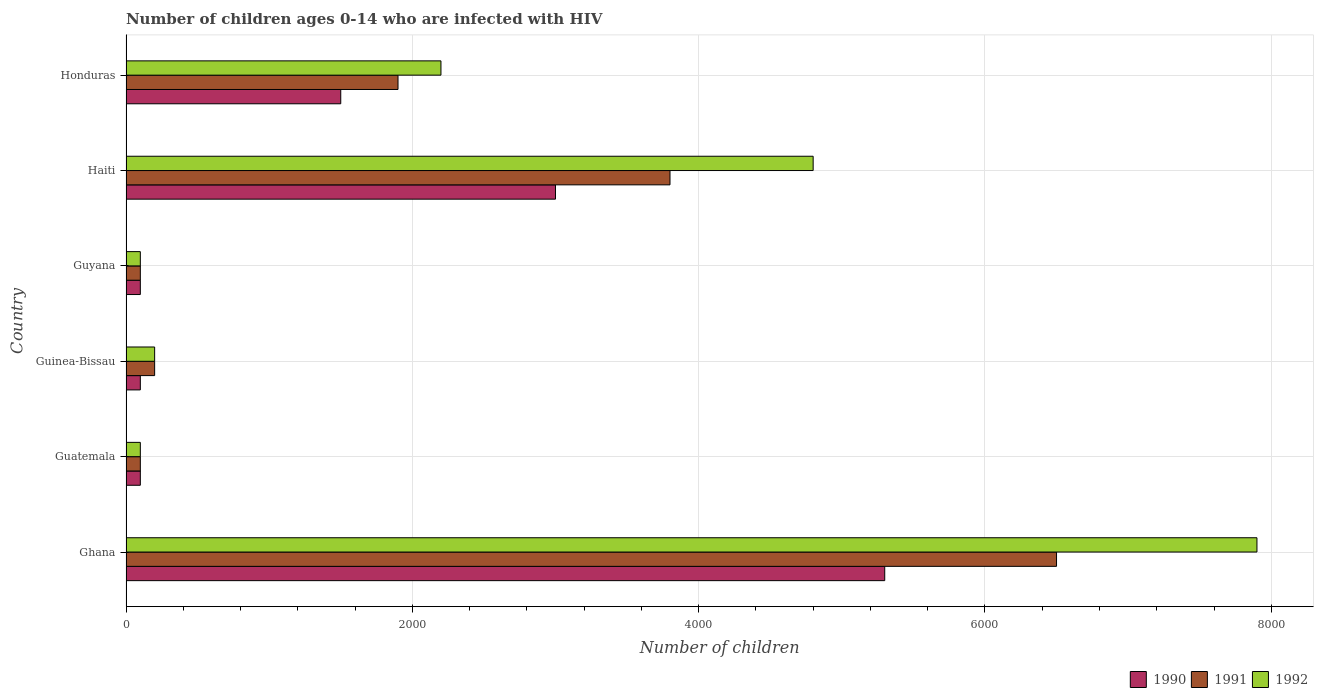How many groups of bars are there?
Your answer should be very brief. 6. Are the number of bars per tick equal to the number of legend labels?
Give a very brief answer. Yes. How many bars are there on the 5th tick from the bottom?
Make the answer very short. 3. What is the label of the 6th group of bars from the top?
Provide a succinct answer. Ghana. In how many cases, is the number of bars for a given country not equal to the number of legend labels?
Provide a short and direct response. 0. What is the number of HIV infected children in 1992 in Guatemala?
Provide a short and direct response. 100. Across all countries, what is the maximum number of HIV infected children in 1990?
Ensure brevity in your answer.  5300. Across all countries, what is the minimum number of HIV infected children in 1990?
Give a very brief answer. 100. In which country was the number of HIV infected children in 1990 maximum?
Your answer should be very brief. Ghana. In which country was the number of HIV infected children in 1992 minimum?
Offer a very short reply. Guatemala. What is the total number of HIV infected children in 1991 in the graph?
Your answer should be very brief. 1.26e+04. What is the difference between the number of HIV infected children in 1992 in Guyana and that in Haiti?
Provide a succinct answer. -4700. What is the difference between the number of HIV infected children in 1991 in Guyana and the number of HIV infected children in 1990 in Guatemala?
Keep it short and to the point. 0. What is the average number of HIV infected children in 1990 per country?
Offer a very short reply. 1683.33. What is the difference between the number of HIV infected children in 1990 and number of HIV infected children in 1991 in Guyana?
Your answer should be compact. 0. In how many countries, is the number of HIV infected children in 1990 greater than 7600 ?
Your answer should be very brief. 0. What is the ratio of the number of HIV infected children in 1990 in Guyana to that in Honduras?
Provide a short and direct response. 0.07. Is the number of HIV infected children in 1990 in Ghana less than that in Guatemala?
Offer a very short reply. No. What is the difference between the highest and the second highest number of HIV infected children in 1990?
Offer a terse response. 2300. What is the difference between the highest and the lowest number of HIV infected children in 1991?
Your response must be concise. 6400. Is the sum of the number of HIV infected children in 1992 in Ghana and Guinea-Bissau greater than the maximum number of HIV infected children in 1991 across all countries?
Give a very brief answer. Yes. What does the 2nd bar from the bottom in Honduras represents?
Offer a very short reply. 1991. Is it the case that in every country, the sum of the number of HIV infected children in 1991 and number of HIV infected children in 1992 is greater than the number of HIV infected children in 1990?
Provide a short and direct response. Yes. How many bars are there?
Offer a terse response. 18. How many countries are there in the graph?
Keep it short and to the point. 6. Does the graph contain grids?
Provide a succinct answer. Yes. Where does the legend appear in the graph?
Give a very brief answer. Bottom right. How many legend labels are there?
Your answer should be very brief. 3. How are the legend labels stacked?
Your answer should be compact. Horizontal. What is the title of the graph?
Give a very brief answer. Number of children ages 0-14 who are infected with HIV. Does "1979" appear as one of the legend labels in the graph?
Ensure brevity in your answer.  No. What is the label or title of the X-axis?
Provide a short and direct response. Number of children. What is the label or title of the Y-axis?
Your answer should be compact. Country. What is the Number of children of 1990 in Ghana?
Your answer should be compact. 5300. What is the Number of children of 1991 in Ghana?
Your answer should be very brief. 6500. What is the Number of children of 1992 in Ghana?
Give a very brief answer. 7900. What is the Number of children of 1991 in Guatemala?
Offer a very short reply. 100. What is the Number of children in 1992 in Guatemala?
Ensure brevity in your answer.  100. What is the Number of children of 1990 in Guinea-Bissau?
Offer a terse response. 100. What is the Number of children of 1991 in Guinea-Bissau?
Provide a short and direct response. 200. What is the Number of children of 1991 in Guyana?
Your response must be concise. 100. What is the Number of children of 1990 in Haiti?
Your response must be concise. 3000. What is the Number of children of 1991 in Haiti?
Provide a short and direct response. 3800. What is the Number of children in 1992 in Haiti?
Ensure brevity in your answer.  4800. What is the Number of children in 1990 in Honduras?
Provide a short and direct response. 1500. What is the Number of children of 1991 in Honduras?
Ensure brevity in your answer.  1900. What is the Number of children of 1992 in Honduras?
Your answer should be very brief. 2200. Across all countries, what is the maximum Number of children of 1990?
Give a very brief answer. 5300. Across all countries, what is the maximum Number of children in 1991?
Keep it short and to the point. 6500. Across all countries, what is the maximum Number of children of 1992?
Your response must be concise. 7900. Across all countries, what is the minimum Number of children of 1991?
Ensure brevity in your answer.  100. Across all countries, what is the minimum Number of children of 1992?
Your answer should be compact. 100. What is the total Number of children of 1990 in the graph?
Make the answer very short. 1.01e+04. What is the total Number of children of 1991 in the graph?
Offer a very short reply. 1.26e+04. What is the total Number of children of 1992 in the graph?
Keep it short and to the point. 1.53e+04. What is the difference between the Number of children in 1990 in Ghana and that in Guatemala?
Make the answer very short. 5200. What is the difference between the Number of children in 1991 in Ghana and that in Guatemala?
Ensure brevity in your answer.  6400. What is the difference between the Number of children of 1992 in Ghana and that in Guatemala?
Provide a succinct answer. 7800. What is the difference between the Number of children in 1990 in Ghana and that in Guinea-Bissau?
Your answer should be very brief. 5200. What is the difference between the Number of children in 1991 in Ghana and that in Guinea-Bissau?
Your response must be concise. 6300. What is the difference between the Number of children of 1992 in Ghana and that in Guinea-Bissau?
Your answer should be very brief. 7700. What is the difference between the Number of children in 1990 in Ghana and that in Guyana?
Ensure brevity in your answer.  5200. What is the difference between the Number of children in 1991 in Ghana and that in Guyana?
Your response must be concise. 6400. What is the difference between the Number of children in 1992 in Ghana and that in Guyana?
Ensure brevity in your answer.  7800. What is the difference between the Number of children in 1990 in Ghana and that in Haiti?
Provide a short and direct response. 2300. What is the difference between the Number of children in 1991 in Ghana and that in Haiti?
Your answer should be compact. 2700. What is the difference between the Number of children in 1992 in Ghana and that in Haiti?
Your answer should be very brief. 3100. What is the difference between the Number of children of 1990 in Ghana and that in Honduras?
Your answer should be very brief. 3800. What is the difference between the Number of children of 1991 in Ghana and that in Honduras?
Keep it short and to the point. 4600. What is the difference between the Number of children of 1992 in Ghana and that in Honduras?
Offer a very short reply. 5700. What is the difference between the Number of children of 1991 in Guatemala and that in Guinea-Bissau?
Ensure brevity in your answer.  -100. What is the difference between the Number of children of 1992 in Guatemala and that in Guinea-Bissau?
Your answer should be compact. -100. What is the difference between the Number of children of 1990 in Guatemala and that in Guyana?
Your answer should be compact. 0. What is the difference between the Number of children of 1991 in Guatemala and that in Guyana?
Offer a terse response. 0. What is the difference between the Number of children in 1990 in Guatemala and that in Haiti?
Your answer should be very brief. -2900. What is the difference between the Number of children of 1991 in Guatemala and that in Haiti?
Ensure brevity in your answer.  -3700. What is the difference between the Number of children of 1992 in Guatemala and that in Haiti?
Your response must be concise. -4700. What is the difference between the Number of children in 1990 in Guatemala and that in Honduras?
Your response must be concise. -1400. What is the difference between the Number of children of 1991 in Guatemala and that in Honduras?
Ensure brevity in your answer.  -1800. What is the difference between the Number of children of 1992 in Guatemala and that in Honduras?
Give a very brief answer. -2100. What is the difference between the Number of children of 1990 in Guinea-Bissau and that in Guyana?
Your response must be concise. 0. What is the difference between the Number of children in 1990 in Guinea-Bissau and that in Haiti?
Give a very brief answer. -2900. What is the difference between the Number of children of 1991 in Guinea-Bissau and that in Haiti?
Offer a very short reply. -3600. What is the difference between the Number of children in 1992 in Guinea-Bissau and that in Haiti?
Offer a very short reply. -4600. What is the difference between the Number of children of 1990 in Guinea-Bissau and that in Honduras?
Give a very brief answer. -1400. What is the difference between the Number of children of 1991 in Guinea-Bissau and that in Honduras?
Give a very brief answer. -1700. What is the difference between the Number of children of 1992 in Guinea-Bissau and that in Honduras?
Give a very brief answer. -2000. What is the difference between the Number of children in 1990 in Guyana and that in Haiti?
Make the answer very short. -2900. What is the difference between the Number of children in 1991 in Guyana and that in Haiti?
Your answer should be very brief. -3700. What is the difference between the Number of children of 1992 in Guyana and that in Haiti?
Your response must be concise. -4700. What is the difference between the Number of children in 1990 in Guyana and that in Honduras?
Offer a very short reply. -1400. What is the difference between the Number of children in 1991 in Guyana and that in Honduras?
Give a very brief answer. -1800. What is the difference between the Number of children in 1992 in Guyana and that in Honduras?
Your answer should be very brief. -2100. What is the difference between the Number of children of 1990 in Haiti and that in Honduras?
Offer a terse response. 1500. What is the difference between the Number of children in 1991 in Haiti and that in Honduras?
Provide a short and direct response. 1900. What is the difference between the Number of children of 1992 in Haiti and that in Honduras?
Offer a very short reply. 2600. What is the difference between the Number of children of 1990 in Ghana and the Number of children of 1991 in Guatemala?
Ensure brevity in your answer.  5200. What is the difference between the Number of children of 1990 in Ghana and the Number of children of 1992 in Guatemala?
Ensure brevity in your answer.  5200. What is the difference between the Number of children of 1991 in Ghana and the Number of children of 1992 in Guatemala?
Keep it short and to the point. 6400. What is the difference between the Number of children of 1990 in Ghana and the Number of children of 1991 in Guinea-Bissau?
Your response must be concise. 5100. What is the difference between the Number of children in 1990 in Ghana and the Number of children in 1992 in Guinea-Bissau?
Make the answer very short. 5100. What is the difference between the Number of children in 1991 in Ghana and the Number of children in 1992 in Guinea-Bissau?
Your answer should be very brief. 6300. What is the difference between the Number of children of 1990 in Ghana and the Number of children of 1991 in Guyana?
Your answer should be very brief. 5200. What is the difference between the Number of children in 1990 in Ghana and the Number of children in 1992 in Guyana?
Make the answer very short. 5200. What is the difference between the Number of children of 1991 in Ghana and the Number of children of 1992 in Guyana?
Provide a short and direct response. 6400. What is the difference between the Number of children in 1990 in Ghana and the Number of children in 1991 in Haiti?
Provide a short and direct response. 1500. What is the difference between the Number of children in 1990 in Ghana and the Number of children in 1992 in Haiti?
Provide a succinct answer. 500. What is the difference between the Number of children in 1991 in Ghana and the Number of children in 1992 in Haiti?
Your answer should be very brief. 1700. What is the difference between the Number of children of 1990 in Ghana and the Number of children of 1991 in Honduras?
Ensure brevity in your answer.  3400. What is the difference between the Number of children of 1990 in Ghana and the Number of children of 1992 in Honduras?
Make the answer very short. 3100. What is the difference between the Number of children in 1991 in Ghana and the Number of children in 1992 in Honduras?
Provide a succinct answer. 4300. What is the difference between the Number of children in 1990 in Guatemala and the Number of children in 1991 in Guinea-Bissau?
Keep it short and to the point. -100. What is the difference between the Number of children of 1990 in Guatemala and the Number of children of 1992 in Guinea-Bissau?
Make the answer very short. -100. What is the difference between the Number of children of 1991 in Guatemala and the Number of children of 1992 in Guinea-Bissau?
Make the answer very short. -100. What is the difference between the Number of children in 1990 in Guatemala and the Number of children in 1991 in Guyana?
Your response must be concise. 0. What is the difference between the Number of children in 1990 in Guatemala and the Number of children in 1992 in Guyana?
Provide a short and direct response. 0. What is the difference between the Number of children in 1991 in Guatemala and the Number of children in 1992 in Guyana?
Provide a succinct answer. 0. What is the difference between the Number of children of 1990 in Guatemala and the Number of children of 1991 in Haiti?
Provide a succinct answer. -3700. What is the difference between the Number of children in 1990 in Guatemala and the Number of children in 1992 in Haiti?
Offer a terse response. -4700. What is the difference between the Number of children in 1991 in Guatemala and the Number of children in 1992 in Haiti?
Keep it short and to the point. -4700. What is the difference between the Number of children in 1990 in Guatemala and the Number of children in 1991 in Honduras?
Give a very brief answer. -1800. What is the difference between the Number of children of 1990 in Guatemala and the Number of children of 1992 in Honduras?
Your answer should be compact. -2100. What is the difference between the Number of children in 1991 in Guatemala and the Number of children in 1992 in Honduras?
Keep it short and to the point. -2100. What is the difference between the Number of children in 1990 in Guinea-Bissau and the Number of children in 1992 in Guyana?
Provide a succinct answer. 0. What is the difference between the Number of children in 1991 in Guinea-Bissau and the Number of children in 1992 in Guyana?
Provide a succinct answer. 100. What is the difference between the Number of children in 1990 in Guinea-Bissau and the Number of children in 1991 in Haiti?
Your answer should be compact. -3700. What is the difference between the Number of children in 1990 in Guinea-Bissau and the Number of children in 1992 in Haiti?
Provide a succinct answer. -4700. What is the difference between the Number of children of 1991 in Guinea-Bissau and the Number of children of 1992 in Haiti?
Keep it short and to the point. -4600. What is the difference between the Number of children of 1990 in Guinea-Bissau and the Number of children of 1991 in Honduras?
Provide a short and direct response. -1800. What is the difference between the Number of children of 1990 in Guinea-Bissau and the Number of children of 1992 in Honduras?
Give a very brief answer. -2100. What is the difference between the Number of children of 1991 in Guinea-Bissau and the Number of children of 1992 in Honduras?
Give a very brief answer. -2000. What is the difference between the Number of children in 1990 in Guyana and the Number of children in 1991 in Haiti?
Provide a short and direct response. -3700. What is the difference between the Number of children in 1990 in Guyana and the Number of children in 1992 in Haiti?
Offer a terse response. -4700. What is the difference between the Number of children of 1991 in Guyana and the Number of children of 1992 in Haiti?
Provide a succinct answer. -4700. What is the difference between the Number of children of 1990 in Guyana and the Number of children of 1991 in Honduras?
Provide a succinct answer. -1800. What is the difference between the Number of children in 1990 in Guyana and the Number of children in 1992 in Honduras?
Give a very brief answer. -2100. What is the difference between the Number of children of 1991 in Guyana and the Number of children of 1992 in Honduras?
Provide a short and direct response. -2100. What is the difference between the Number of children in 1990 in Haiti and the Number of children in 1991 in Honduras?
Ensure brevity in your answer.  1100. What is the difference between the Number of children in 1990 in Haiti and the Number of children in 1992 in Honduras?
Provide a short and direct response. 800. What is the difference between the Number of children in 1991 in Haiti and the Number of children in 1992 in Honduras?
Your answer should be compact. 1600. What is the average Number of children in 1990 per country?
Keep it short and to the point. 1683.33. What is the average Number of children of 1991 per country?
Ensure brevity in your answer.  2100. What is the average Number of children in 1992 per country?
Offer a terse response. 2550. What is the difference between the Number of children in 1990 and Number of children in 1991 in Ghana?
Make the answer very short. -1200. What is the difference between the Number of children of 1990 and Number of children of 1992 in Ghana?
Your answer should be very brief. -2600. What is the difference between the Number of children in 1991 and Number of children in 1992 in Ghana?
Your response must be concise. -1400. What is the difference between the Number of children in 1990 and Number of children in 1991 in Guatemala?
Offer a terse response. 0. What is the difference between the Number of children in 1990 and Number of children in 1991 in Guinea-Bissau?
Provide a succinct answer. -100. What is the difference between the Number of children in 1990 and Number of children in 1992 in Guinea-Bissau?
Provide a short and direct response. -100. What is the difference between the Number of children in 1991 and Number of children in 1992 in Guinea-Bissau?
Your answer should be very brief. 0. What is the difference between the Number of children in 1990 and Number of children in 1991 in Haiti?
Make the answer very short. -800. What is the difference between the Number of children in 1990 and Number of children in 1992 in Haiti?
Offer a very short reply. -1800. What is the difference between the Number of children in 1991 and Number of children in 1992 in Haiti?
Make the answer very short. -1000. What is the difference between the Number of children of 1990 and Number of children of 1991 in Honduras?
Offer a terse response. -400. What is the difference between the Number of children in 1990 and Number of children in 1992 in Honduras?
Your answer should be compact. -700. What is the difference between the Number of children of 1991 and Number of children of 1992 in Honduras?
Keep it short and to the point. -300. What is the ratio of the Number of children in 1990 in Ghana to that in Guatemala?
Offer a terse response. 53. What is the ratio of the Number of children in 1991 in Ghana to that in Guatemala?
Offer a very short reply. 65. What is the ratio of the Number of children of 1992 in Ghana to that in Guatemala?
Your answer should be very brief. 79. What is the ratio of the Number of children of 1990 in Ghana to that in Guinea-Bissau?
Your answer should be very brief. 53. What is the ratio of the Number of children of 1991 in Ghana to that in Guinea-Bissau?
Keep it short and to the point. 32.5. What is the ratio of the Number of children of 1992 in Ghana to that in Guinea-Bissau?
Give a very brief answer. 39.5. What is the ratio of the Number of children in 1991 in Ghana to that in Guyana?
Make the answer very short. 65. What is the ratio of the Number of children of 1992 in Ghana to that in Guyana?
Your response must be concise. 79. What is the ratio of the Number of children of 1990 in Ghana to that in Haiti?
Provide a succinct answer. 1.77. What is the ratio of the Number of children in 1991 in Ghana to that in Haiti?
Ensure brevity in your answer.  1.71. What is the ratio of the Number of children in 1992 in Ghana to that in Haiti?
Provide a short and direct response. 1.65. What is the ratio of the Number of children in 1990 in Ghana to that in Honduras?
Offer a terse response. 3.53. What is the ratio of the Number of children of 1991 in Ghana to that in Honduras?
Give a very brief answer. 3.42. What is the ratio of the Number of children in 1992 in Ghana to that in Honduras?
Make the answer very short. 3.59. What is the ratio of the Number of children in 1990 in Guatemala to that in Guinea-Bissau?
Your answer should be compact. 1. What is the ratio of the Number of children of 1990 in Guatemala to that in Haiti?
Offer a very short reply. 0.03. What is the ratio of the Number of children of 1991 in Guatemala to that in Haiti?
Your response must be concise. 0.03. What is the ratio of the Number of children of 1992 in Guatemala to that in Haiti?
Keep it short and to the point. 0.02. What is the ratio of the Number of children of 1990 in Guatemala to that in Honduras?
Offer a very short reply. 0.07. What is the ratio of the Number of children of 1991 in Guatemala to that in Honduras?
Your response must be concise. 0.05. What is the ratio of the Number of children of 1992 in Guatemala to that in Honduras?
Provide a short and direct response. 0.05. What is the ratio of the Number of children of 1991 in Guinea-Bissau to that in Guyana?
Keep it short and to the point. 2. What is the ratio of the Number of children in 1992 in Guinea-Bissau to that in Guyana?
Make the answer very short. 2. What is the ratio of the Number of children of 1991 in Guinea-Bissau to that in Haiti?
Your answer should be very brief. 0.05. What is the ratio of the Number of children in 1992 in Guinea-Bissau to that in Haiti?
Your response must be concise. 0.04. What is the ratio of the Number of children of 1990 in Guinea-Bissau to that in Honduras?
Provide a short and direct response. 0.07. What is the ratio of the Number of children in 1991 in Guinea-Bissau to that in Honduras?
Your response must be concise. 0.11. What is the ratio of the Number of children in 1992 in Guinea-Bissau to that in Honduras?
Provide a succinct answer. 0.09. What is the ratio of the Number of children in 1990 in Guyana to that in Haiti?
Make the answer very short. 0.03. What is the ratio of the Number of children of 1991 in Guyana to that in Haiti?
Provide a short and direct response. 0.03. What is the ratio of the Number of children in 1992 in Guyana to that in Haiti?
Keep it short and to the point. 0.02. What is the ratio of the Number of children in 1990 in Guyana to that in Honduras?
Keep it short and to the point. 0.07. What is the ratio of the Number of children in 1991 in Guyana to that in Honduras?
Ensure brevity in your answer.  0.05. What is the ratio of the Number of children of 1992 in Guyana to that in Honduras?
Make the answer very short. 0.05. What is the ratio of the Number of children in 1992 in Haiti to that in Honduras?
Ensure brevity in your answer.  2.18. What is the difference between the highest and the second highest Number of children of 1990?
Give a very brief answer. 2300. What is the difference between the highest and the second highest Number of children in 1991?
Offer a very short reply. 2700. What is the difference between the highest and the second highest Number of children in 1992?
Provide a short and direct response. 3100. What is the difference between the highest and the lowest Number of children of 1990?
Keep it short and to the point. 5200. What is the difference between the highest and the lowest Number of children in 1991?
Keep it short and to the point. 6400. What is the difference between the highest and the lowest Number of children of 1992?
Provide a short and direct response. 7800. 